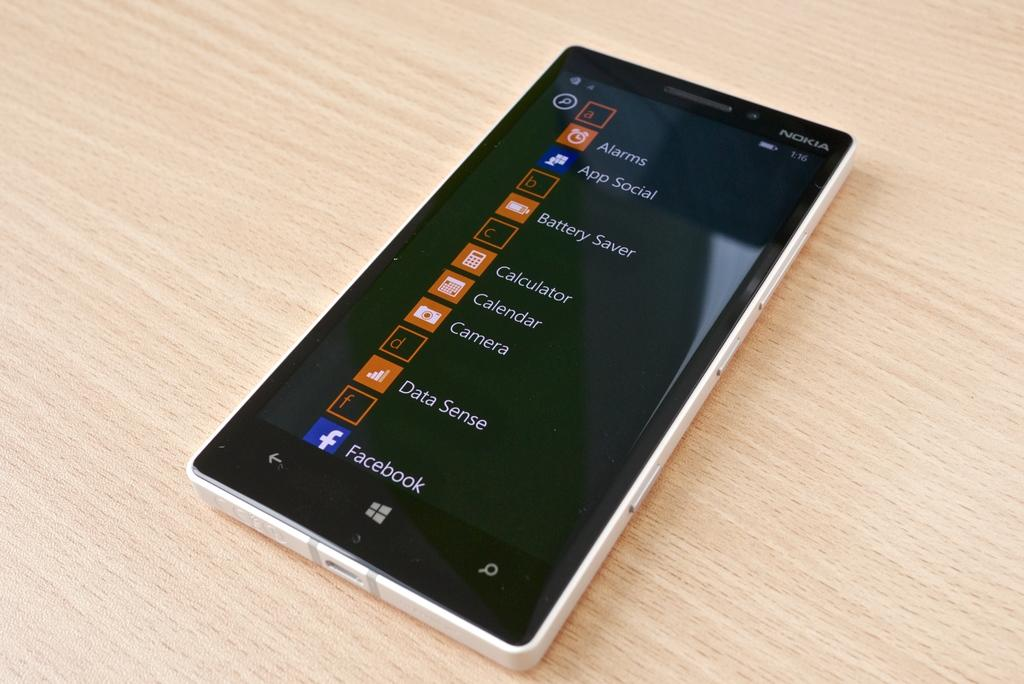<image>
Create a compact narrative representing the image presented. A smart phone with alarms on the top of the list 